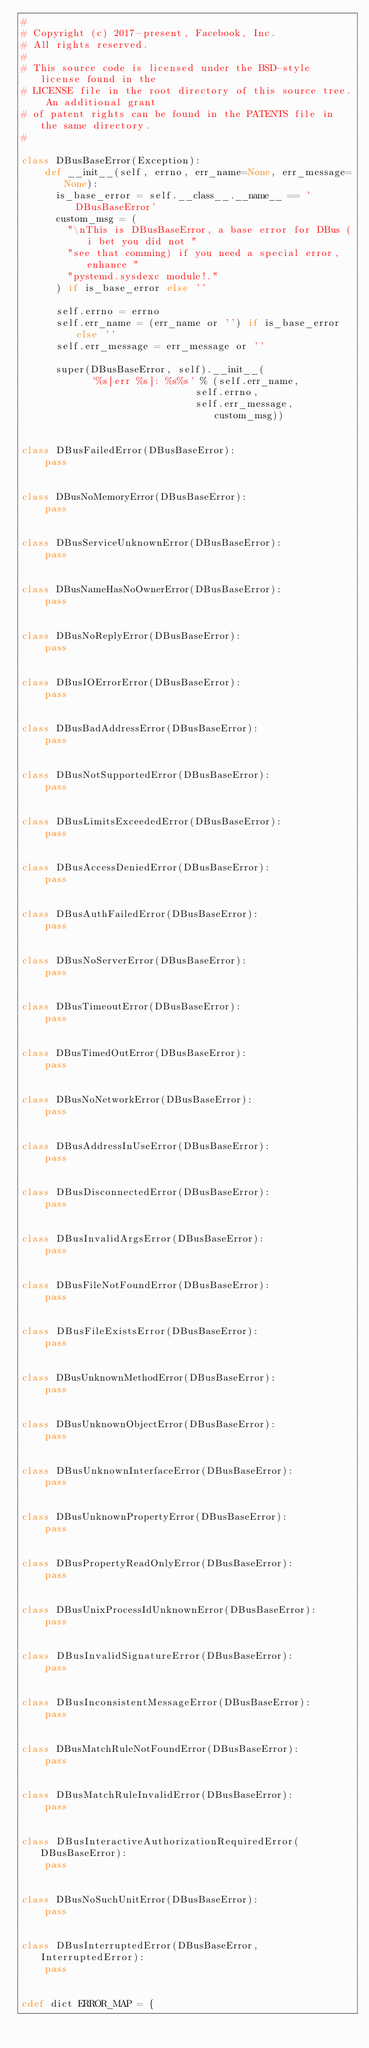<code> <loc_0><loc_0><loc_500><loc_500><_Cython_>#
# Copyright (c) 2017-present, Facebook, Inc.
# All rights reserved.
#
# This source code is licensed under the BSD-style license found in the
# LICENSE file in the root directory of this source tree. An additional grant
# of patent rights can be found in the PATENTS file in the same directory.
#

class DBusBaseError(Exception):
    def __init__(self, errno, err_name=None, err_message=None):
      is_base_error = self.__class__.__name__ == 'DBusBaseError'
      custom_msg = (
        "\nThis is DBusBaseError, a base error for DBus (i bet you did not "
        "see that comming) if you need a special error, enhance "
        "pystemd.sysdexc module!."
      ) if is_base_error else ''

      self.errno = errno
      self.err_name = (err_name or '') if is_base_error else ''
      self.err_message = err_message or ''

      super(DBusBaseError, self).__init__(
            '%s[err %s]: %s%s' % (self.err_name,
                              self.errno,
                              self.err_message, custom_msg))


class DBusFailedError(DBusBaseError):
    pass


class DBusNoMemoryError(DBusBaseError):
    pass


class DBusServiceUnknownError(DBusBaseError):
    pass


class DBusNameHasNoOwnerError(DBusBaseError):
    pass


class DBusNoReplyError(DBusBaseError):
    pass


class DBusIOErrorError(DBusBaseError):
    pass


class DBusBadAddressError(DBusBaseError):
    pass


class DBusNotSupportedError(DBusBaseError):
    pass


class DBusLimitsExceededError(DBusBaseError):
    pass


class DBusAccessDeniedError(DBusBaseError):
    pass


class DBusAuthFailedError(DBusBaseError):
    pass


class DBusNoServerError(DBusBaseError):
    pass


class DBusTimeoutError(DBusBaseError):
    pass


class DBusTimedOutError(DBusBaseError):
    pass


class DBusNoNetworkError(DBusBaseError):
    pass


class DBusAddressInUseError(DBusBaseError):
    pass


class DBusDisconnectedError(DBusBaseError):
    pass


class DBusInvalidArgsError(DBusBaseError):
    pass


class DBusFileNotFoundError(DBusBaseError):
    pass


class DBusFileExistsError(DBusBaseError):
    pass


class DBusUnknownMethodError(DBusBaseError):
    pass


class DBusUnknownObjectError(DBusBaseError):
    pass


class DBusUnknownInterfaceError(DBusBaseError):
    pass


class DBusUnknownPropertyError(DBusBaseError):
    pass


class DBusPropertyReadOnlyError(DBusBaseError):
    pass


class DBusUnixProcessIdUnknownError(DBusBaseError):
    pass


class DBusInvalidSignatureError(DBusBaseError):
    pass


class DBusInconsistentMessageError(DBusBaseError):
    pass


class DBusMatchRuleNotFoundError(DBusBaseError):
    pass


class DBusMatchRuleInvalidError(DBusBaseError):
    pass


class DBusInteractiveAuthorizationRequiredError(DBusBaseError):
    pass


class DBusNoSuchUnitError(DBusBaseError):
    pass


class DBusInterruptedError(DBusBaseError, InterruptedError):
    pass


cdef dict ERROR_MAP = {</code> 